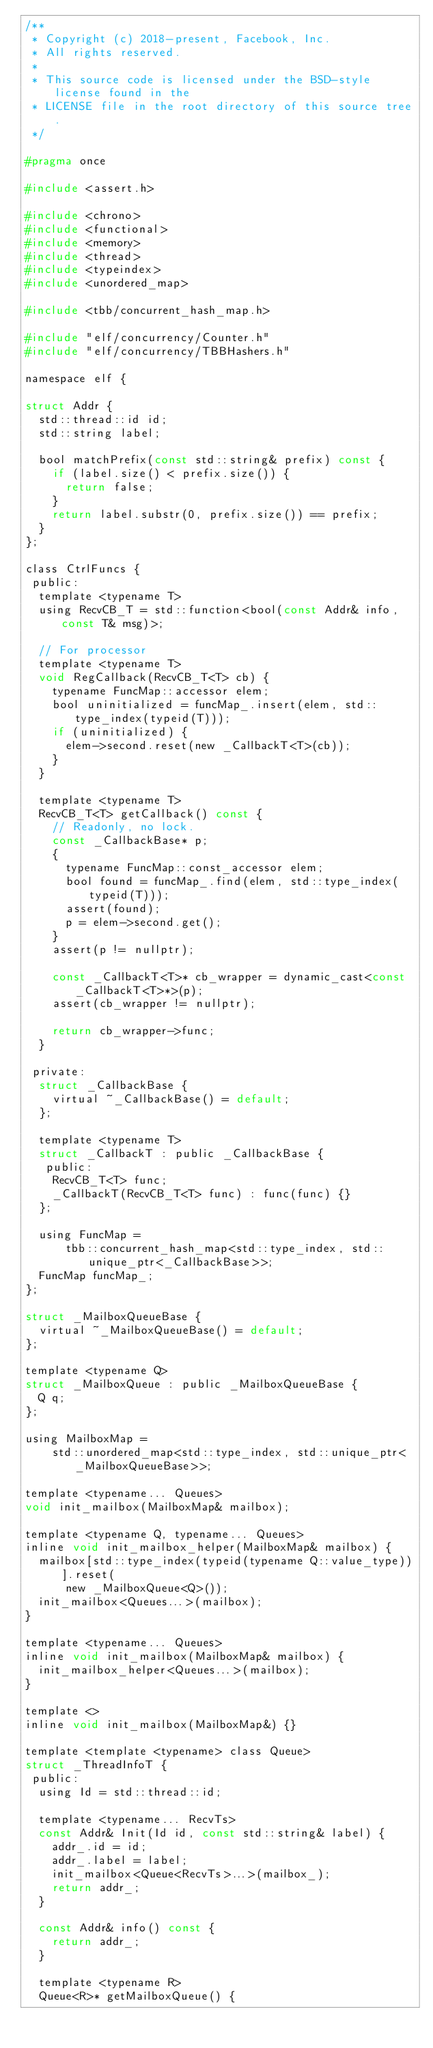Convert code to text. <code><loc_0><loc_0><loc_500><loc_500><_C_>/**
 * Copyright (c) 2018-present, Facebook, Inc.
 * All rights reserved.
 *
 * This source code is licensed under the BSD-style license found in the
 * LICENSE file in the root directory of this source tree.
 */

#pragma once

#include <assert.h>

#include <chrono>
#include <functional>
#include <memory>
#include <thread>
#include <typeindex>
#include <unordered_map>

#include <tbb/concurrent_hash_map.h>

#include "elf/concurrency/Counter.h"
#include "elf/concurrency/TBBHashers.h"

namespace elf {

struct Addr {
  std::thread::id id;
  std::string label;

  bool matchPrefix(const std::string& prefix) const {
    if (label.size() < prefix.size()) {
      return false;
    }
    return label.substr(0, prefix.size()) == prefix;
  }
};

class CtrlFuncs {
 public:
  template <typename T>
  using RecvCB_T = std::function<bool(const Addr& info, const T& msg)>;

  // For processor
  template <typename T>
  void RegCallback(RecvCB_T<T> cb) {
    typename FuncMap::accessor elem;
    bool uninitialized = funcMap_.insert(elem, std::type_index(typeid(T)));
    if (uninitialized) {
      elem->second.reset(new _CallbackT<T>(cb));
    }
  }

  template <typename T>
  RecvCB_T<T> getCallback() const {
    // Readonly, no lock.
    const _CallbackBase* p;
    {
      typename FuncMap::const_accessor elem;
      bool found = funcMap_.find(elem, std::type_index(typeid(T)));
      assert(found);
      p = elem->second.get();
    }
    assert(p != nullptr);

    const _CallbackT<T>* cb_wrapper = dynamic_cast<const _CallbackT<T>*>(p);
    assert(cb_wrapper != nullptr);

    return cb_wrapper->func;
  }

 private:
  struct _CallbackBase {
    virtual ~_CallbackBase() = default;
  };

  template <typename T>
  struct _CallbackT : public _CallbackBase {
   public:
    RecvCB_T<T> func;
    _CallbackT(RecvCB_T<T> func) : func(func) {}
  };

  using FuncMap =
      tbb::concurrent_hash_map<std::type_index, std::unique_ptr<_CallbackBase>>;
  FuncMap funcMap_;
};

struct _MailboxQueueBase {
  virtual ~_MailboxQueueBase() = default;
};

template <typename Q>
struct _MailboxQueue : public _MailboxQueueBase {
  Q q;
};

using MailboxMap =
    std::unordered_map<std::type_index, std::unique_ptr<_MailboxQueueBase>>;

template <typename... Queues>
void init_mailbox(MailboxMap& mailbox);

template <typename Q, typename... Queues>
inline void init_mailbox_helper(MailboxMap& mailbox) {
  mailbox[std::type_index(typeid(typename Q::value_type))].reset(
      new _MailboxQueue<Q>());
  init_mailbox<Queues...>(mailbox);
}

template <typename... Queues>
inline void init_mailbox(MailboxMap& mailbox) {
  init_mailbox_helper<Queues...>(mailbox);
}

template <>
inline void init_mailbox(MailboxMap&) {}

template <template <typename> class Queue>
struct _ThreadInfoT {
 public:
  using Id = std::thread::id;

  template <typename... RecvTs>
  const Addr& Init(Id id, const std::string& label) {
    addr_.id = id;
    addr_.label = label;
    init_mailbox<Queue<RecvTs>...>(mailbox_);
    return addr_;
  }

  const Addr& info() const {
    return addr_;
  }

  template <typename R>
  Queue<R>* getMailboxQueue() {</code> 